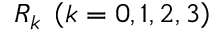<formula> <loc_0><loc_0><loc_500><loc_500>{ R _ { k } } \, \left ( { k = 0 , 1 , 2 , 3 } \right )</formula> 